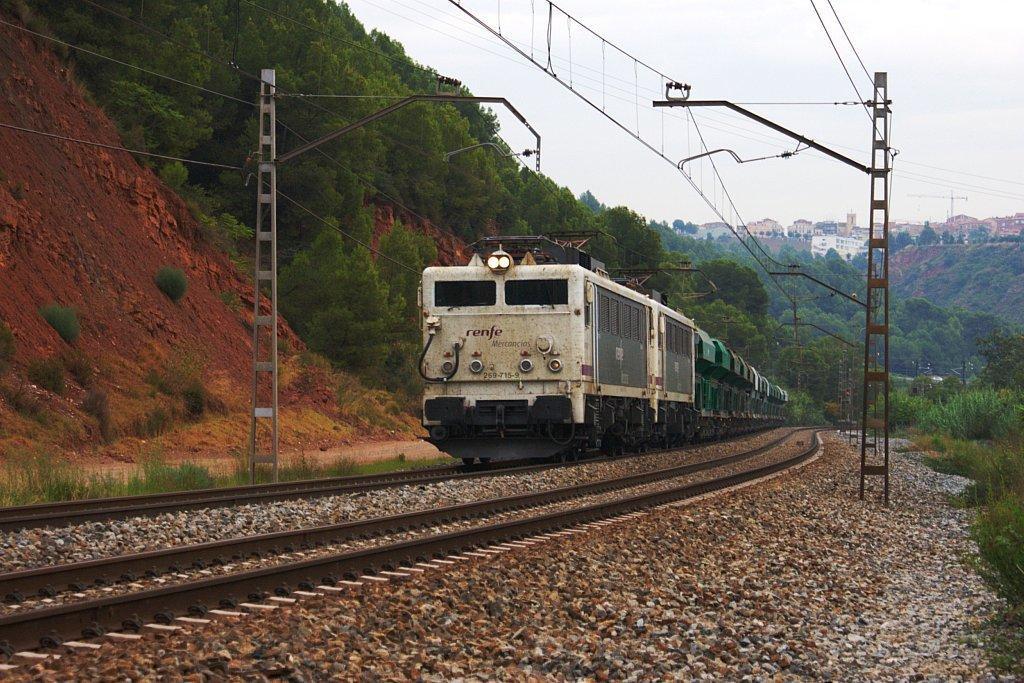Could you give a brief overview of what you see in this image? There is a train on the track. Here we can see poles, wires, plants, and trees. In the background we can see houses and sky. 